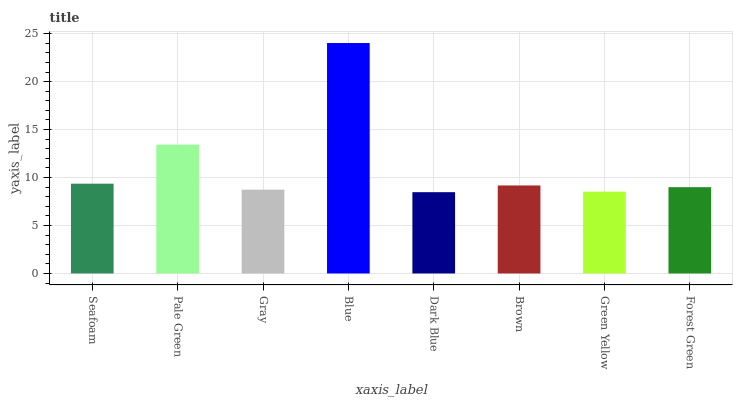Is Dark Blue the minimum?
Answer yes or no. Yes. Is Blue the maximum?
Answer yes or no. Yes. Is Pale Green the minimum?
Answer yes or no. No. Is Pale Green the maximum?
Answer yes or no. No. Is Pale Green greater than Seafoam?
Answer yes or no. Yes. Is Seafoam less than Pale Green?
Answer yes or no. Yes. Is Seafoam greater than Pale Green?
Answer yes or no. No. Is Pale Green less than Seafoam?
Answer yes or no. No. Is Brown the high median?
Answer yes or no. Yes. Is Forest Green the low median?
Answer yes or no. Yes. Is Forest Green the high median?
Answer yes or no. No. Is Seafoam the low median?
Answer yes or no. No. 